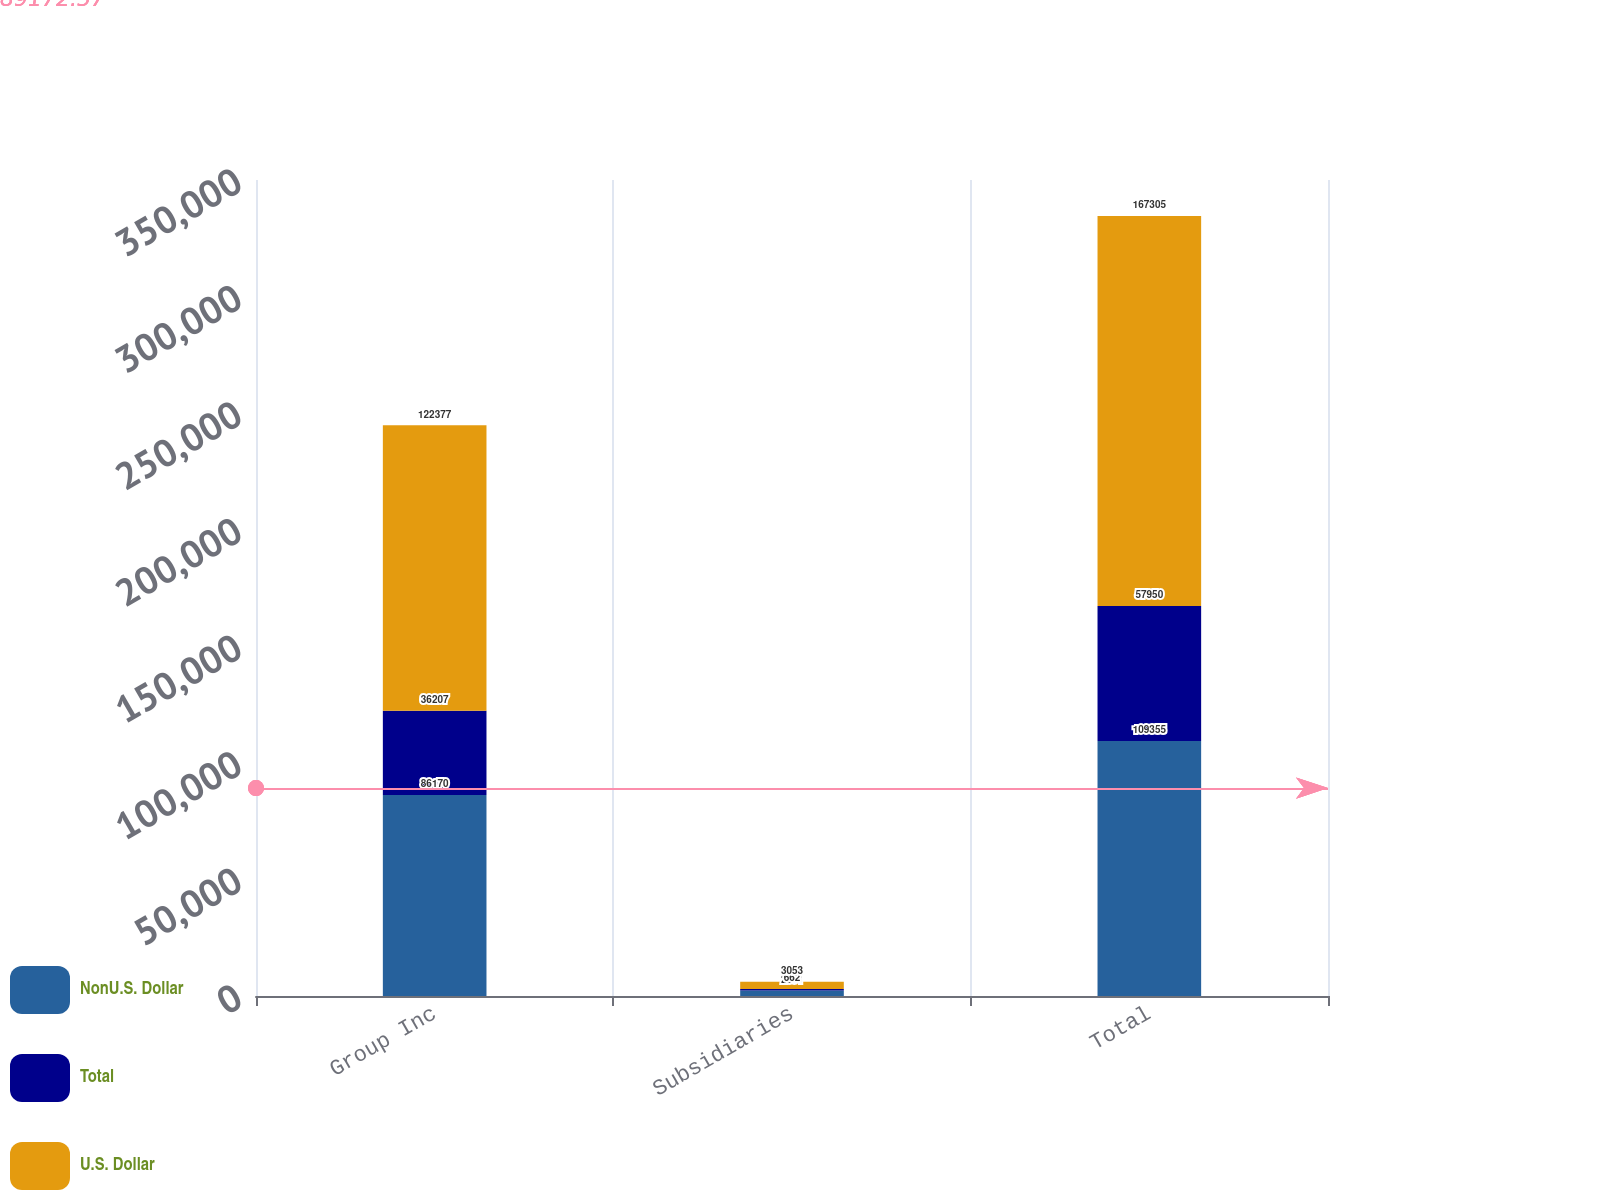Convert chart. <chart><loc_0><loc_0><loc_500><loc_500><stacked_bar_chart><ecel><fcel>Group Inc<fcel>Subsidiaries<fcel>Total<nl><fcel>NonU.S. Dollar<fcel>86170<fcel>2391<fcel>109355<nl><fcel>Total<fcel>36207<fcel>662<fcel>57950<nl><fcel>U.S. Dollar<fcel>122377<fcel>3053<fcel>167305<nl></chart> 